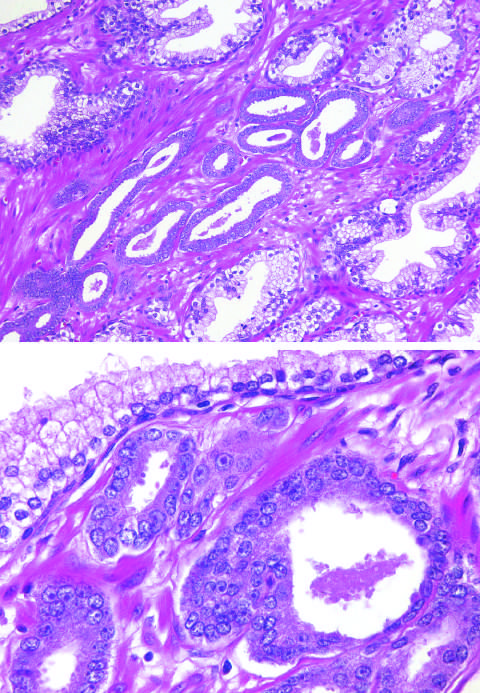re the small glands crowded in between larger benign glands?
Answer the question using a single word or phrase. Yes 